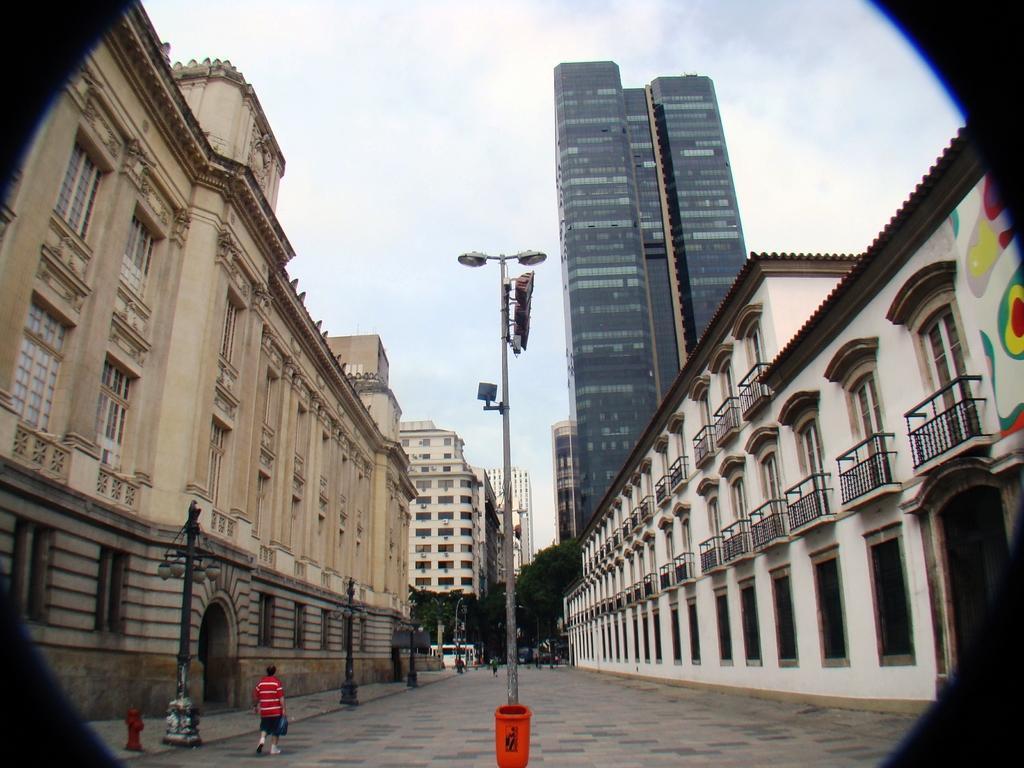In one or two sentences, can you explain what this image depicts? In this image there are some buildings, trees, poles, lights. And at the bottom there is dustbin and some people are walking, and at the bottom of the image there is road and at the top there is sky. 